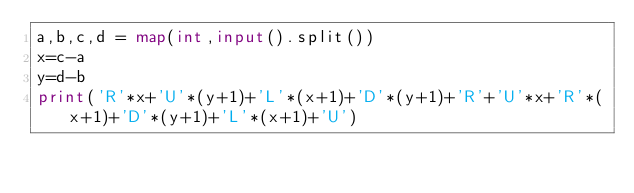Convert code to text. <code><loc_0><loc_0><loc_500><loc_500><_Python_>a,b,c,d = map(int,input().split())
x=c-a
y=d-b
print('R'*x+'U'*(y+1)+'L'*(x+1)+'D'*(y+1)+'R'+'U'*x+'R'*(x+1)+'D'*(y+1)+'L'*(x+1)+'U')
</code> 